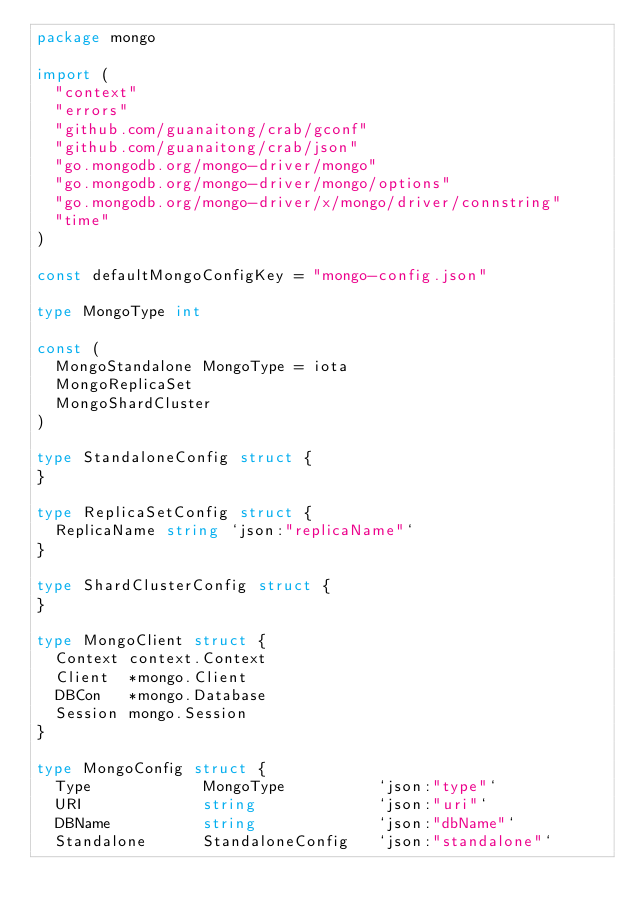Convert code to text. <code><loc_0><loc_0><loc_500><loc_500><_Go_>package mongo

import (
	"context"
	"errors"
	"github.com/guanaitong/crab/gconf"
	"github.com/guanaitong/crab/json"
	"go.mongodb.org/mongo-driver/mongo"
	"go.mongodb.org/mongo-driver/mongo/options"
	"go.mongodb.org/mongo-driver/x/mongo/driver/connstring"
	"time"
)

const defaultMongoConfigKey = "mongo-config.json"

type MongoType int

const (
	MongoStandalone MongoType = iota
	MongoReplicaSet
	MongoShardCluster
)

type StandaloneConfig struct {
}

type ReplicaSetConfig struct {
	ReplicaName string `json:"replicaName"`
}

type ShardClusterConfig struct {
}

type MongoClient struct {
	Context context.Context
	Client  *mongo.Client
	DBCon   *mongo.Database
	Session mongo.Session
}

type MongoConfig struct {
	Type            MongoType          `json:"type"`
	URI             string             `json:"uri"`
	DBName          string             `json:"dbName"`
	Standalone      StandaloneConfig   `json:"standalone"`</code> 